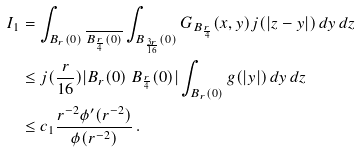<formula> <loc_0><loc_0><loc_500><loc_500>I _ { 1 } & = \int _ { B _ { r } ( 0 ) \ \overline { B _ { \frac { r } { 4 } } ( 0 ) } } \int _ { B _ { \frac { 3 r } { 1 6 } } ( 0 ) } G _ { B _ { \frac { r } { 4 } } } ( x , y ) j ( | z - y | ) \, d y \, d z \\ & \leq j ( \frac { r } { 1 6 } ) | B _ { r } ( 0 ) \ B _ { \frac { r } { 4 } } ( 0 ) | \int _ { B _ { r } ( 0 ) } g ( | y | ) \, d y \, d z \\ & \leq c _ { 1 } \frac { r ^ { - 2 } \phi ^ { \prime } ( r ^ { - 2 } ) } { \phi ( r ^ { - 2 } ) } \, .</formula> 